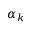<formula> <loc_0><loc_0><loc_500><loc_500>\alpha _ { k }</formula> 